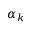<formula> <loc_0><loc_0><loc_500><loc_500>\alpha _ { k }</formula> 